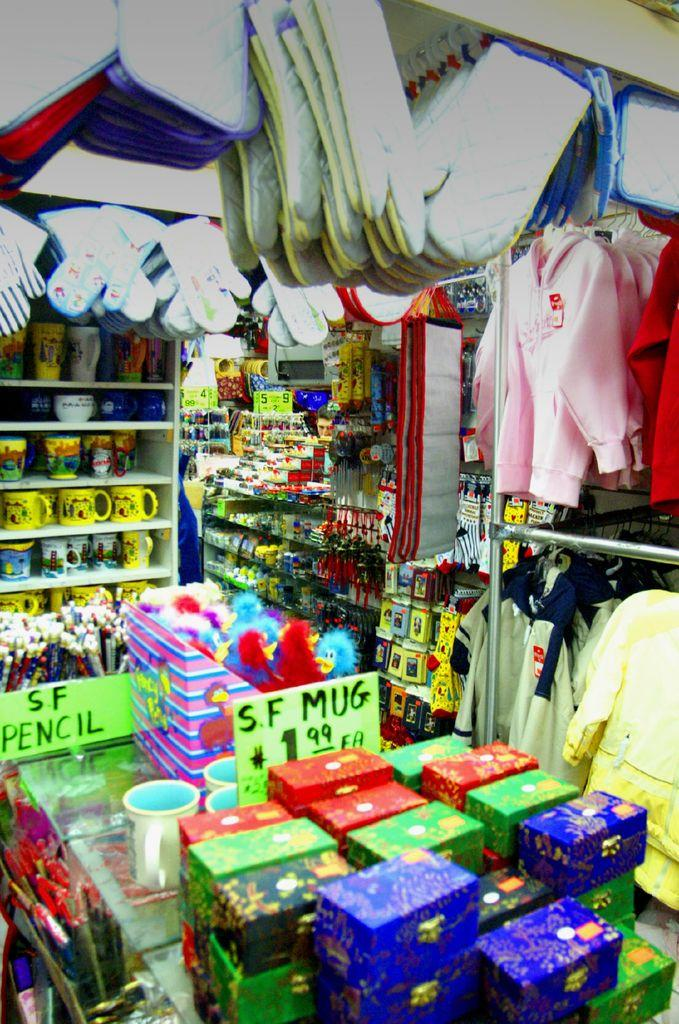<image>
Offer a succinct explanation of the picture presented. The shop is full of nice nick nacks to buy. 